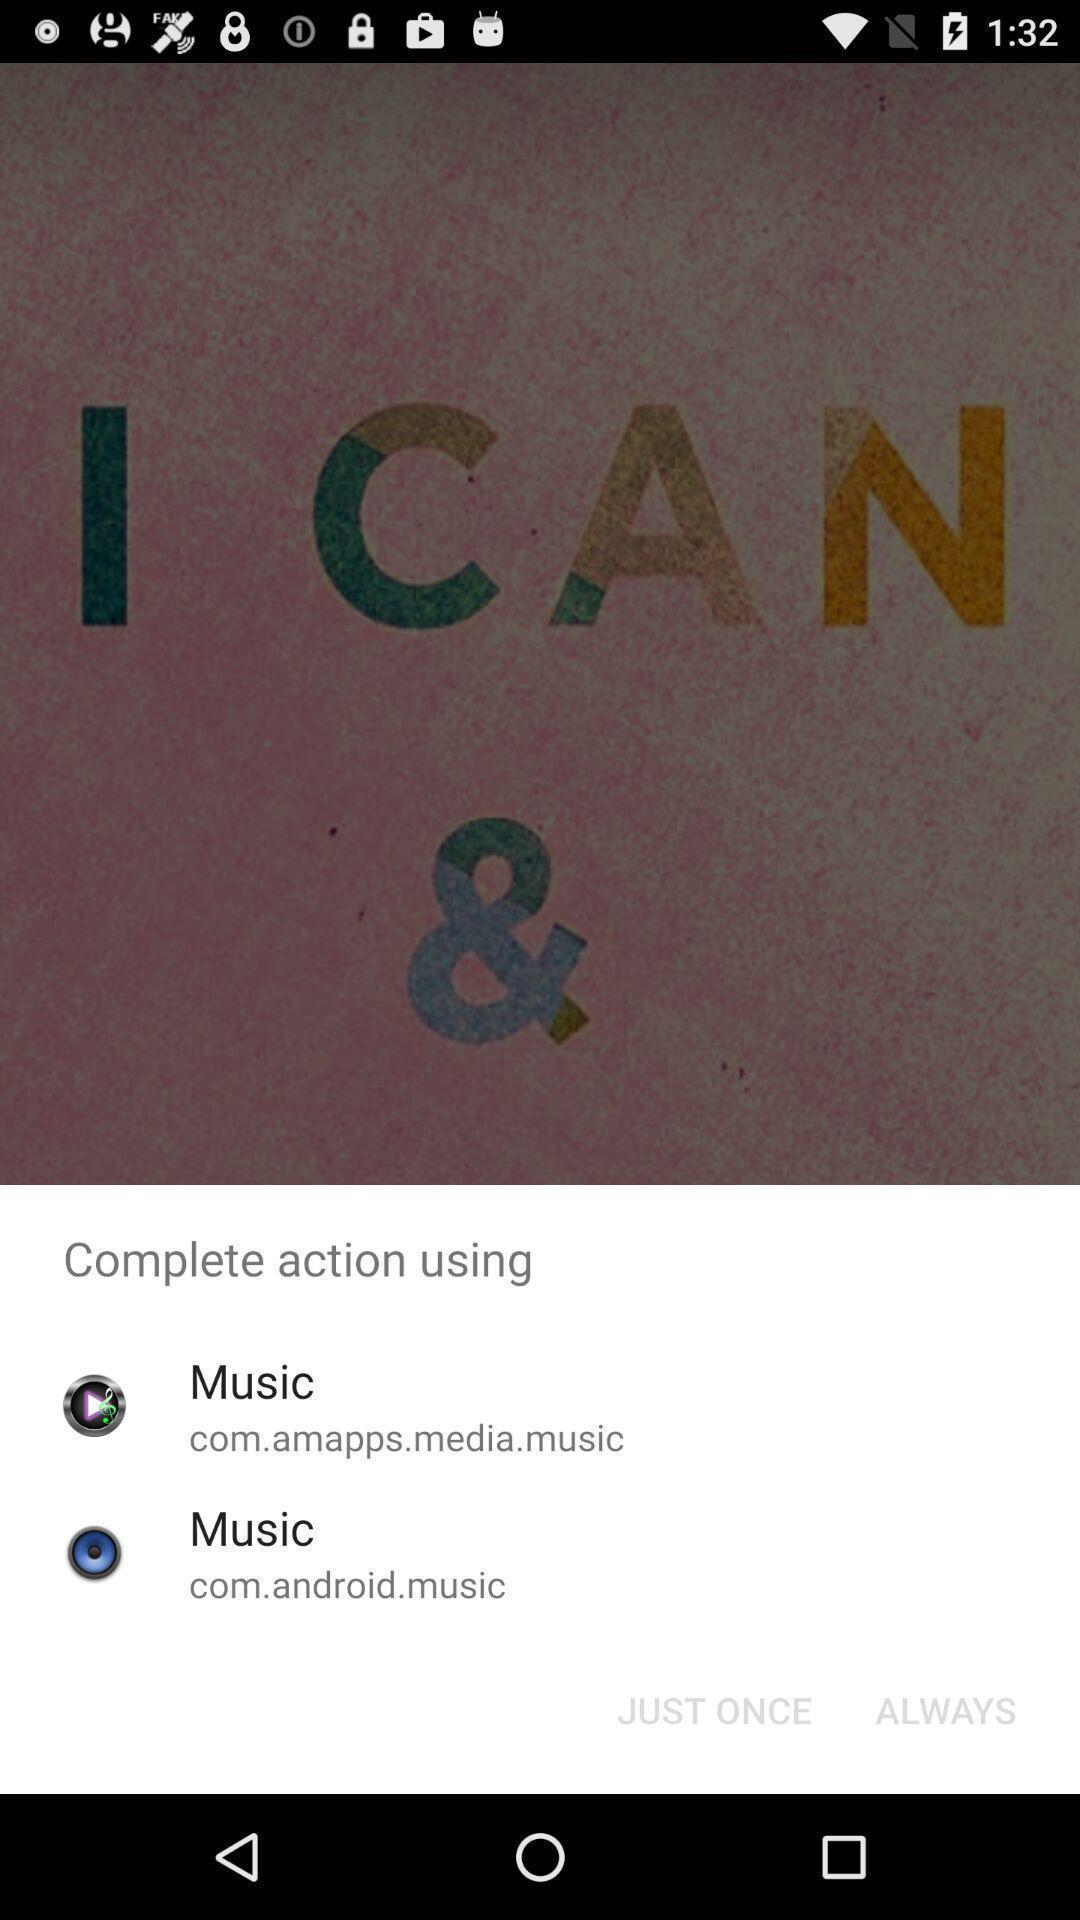What details can you identify in this image? Pop-up showing default options for an app to open with. 